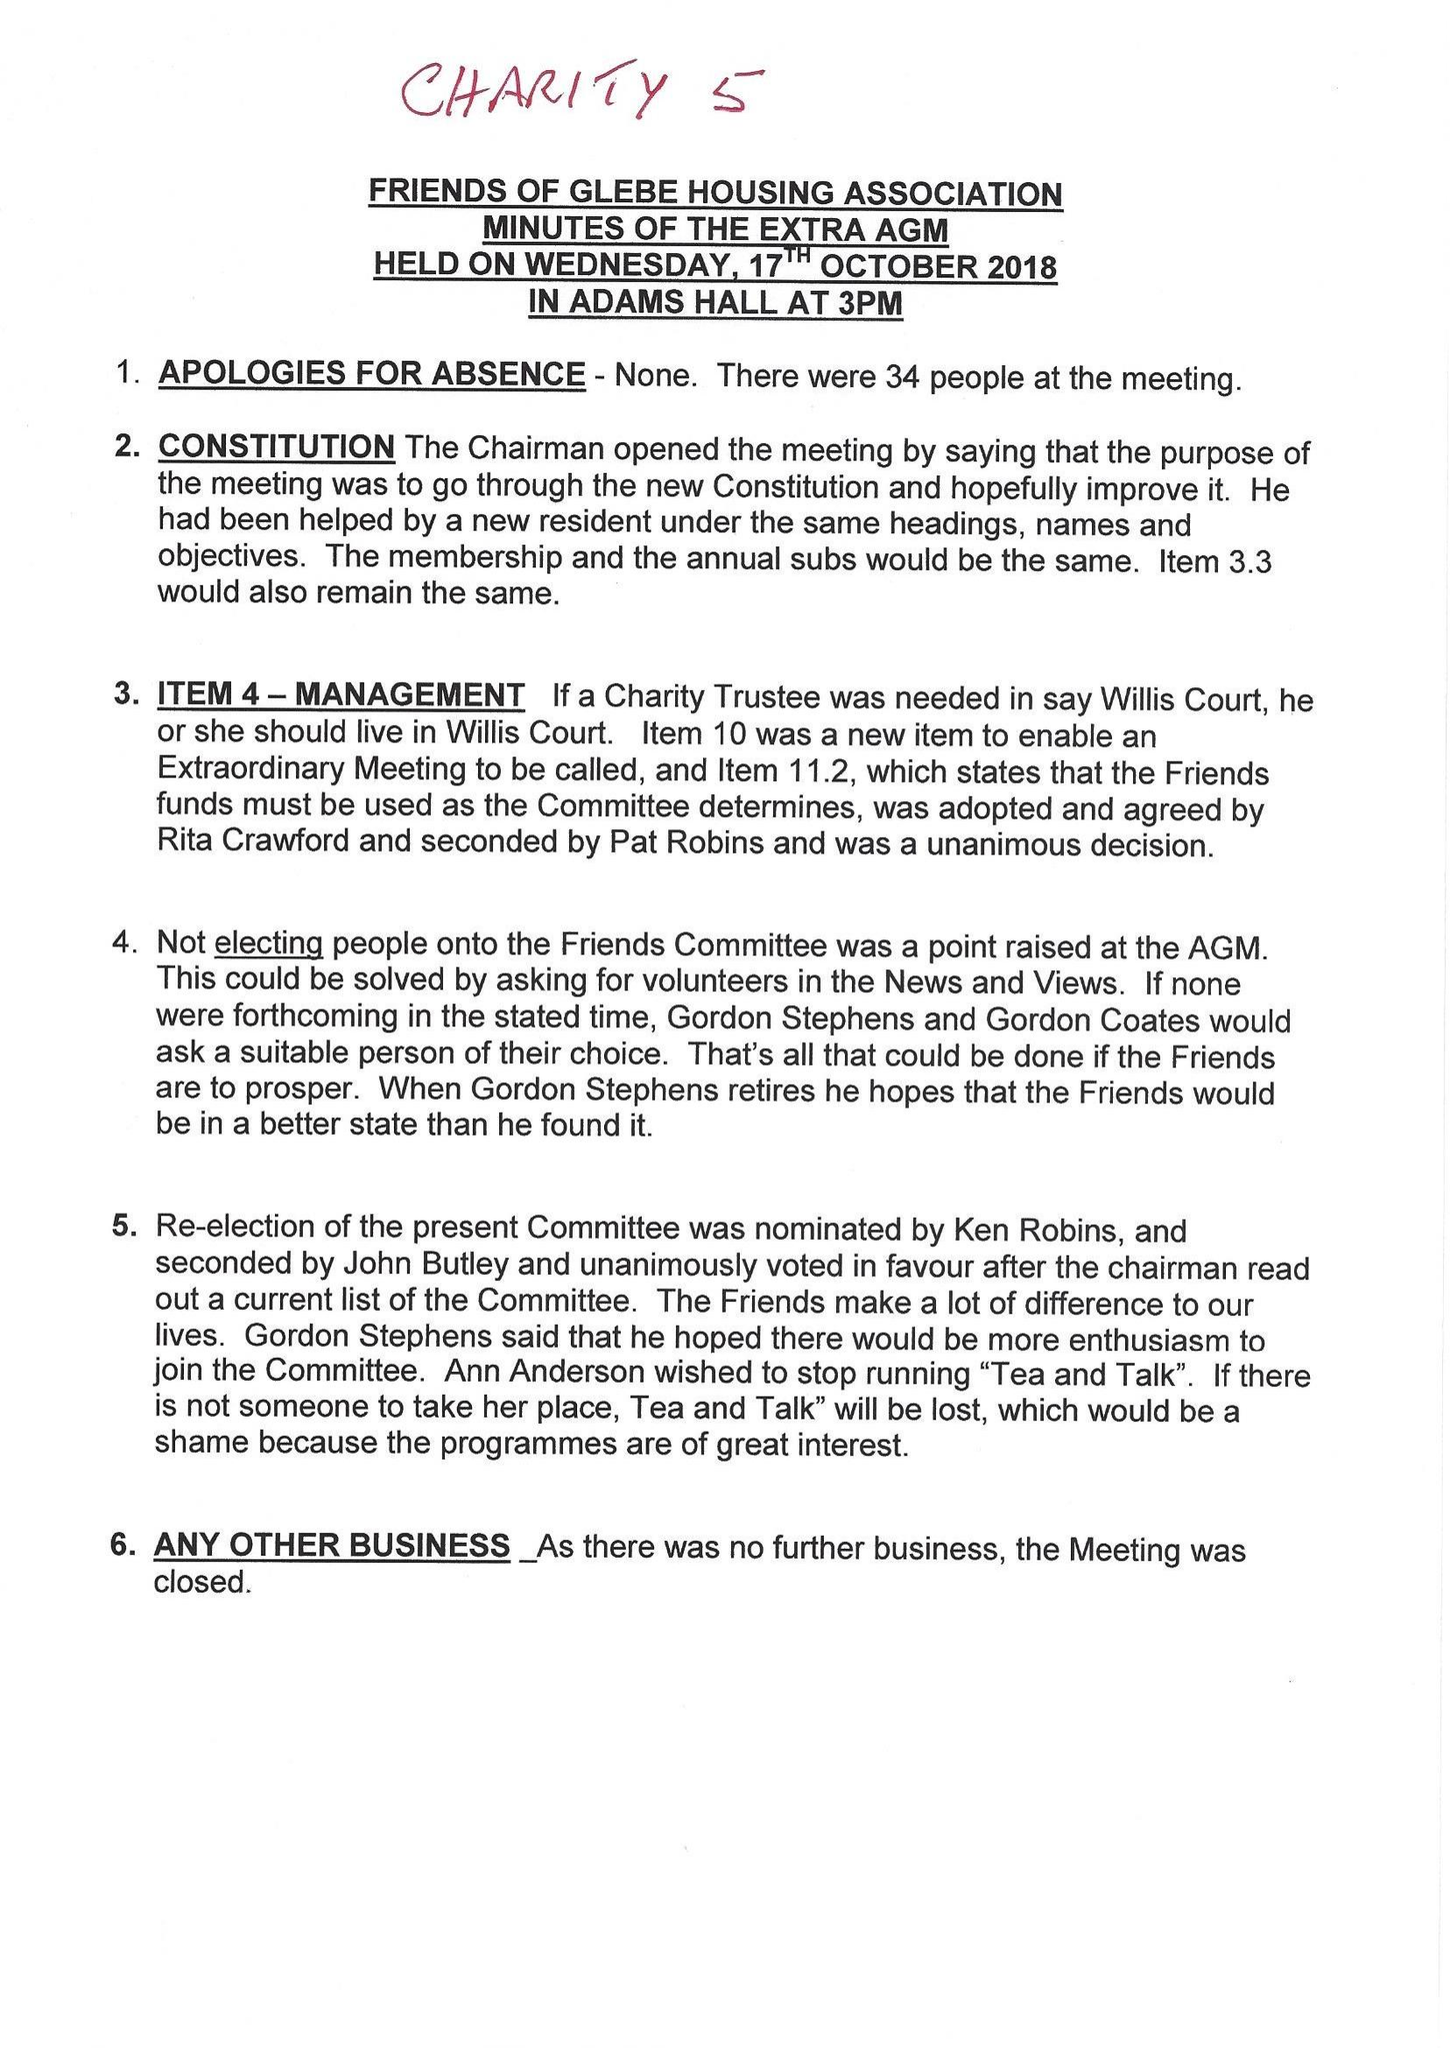What is the value for the income_annually_in_british_pounds?
Answer the question using a single word or phrase. 119588.41 